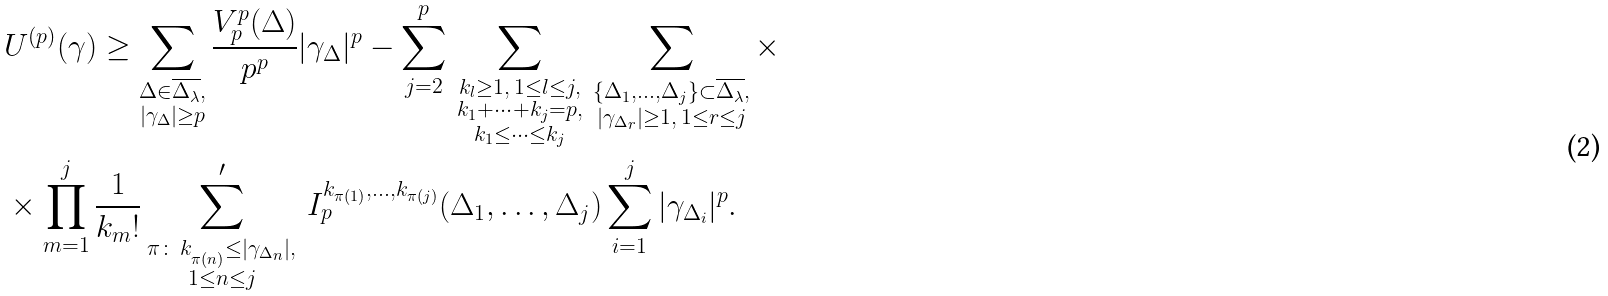<formula> <loc_0><loc_0><loc_500><loc_500>& U ^ { ( p ) } ( \gamma ) \geq \sum _ { \substack { \Delta \in \overline { \Delta _ { \lambda } } , \\ | \gamma _ { \Delta } | \geq p } } \frac { V _ { p } ^ { p } ( \Delta ) } { p ^ { p } } | \gamma _ { \Delta } | ^ { p } - \sum _ { j = 2 } ^ { p } \, \sum _ { \substack { k _ { l } \geq 1 , \, 1 \leq l \leq j , \\ k _ { 1 } + \cdots + k _ { j } = p , \\ k _ { 1 } \leq \dots \leq k _ { j } } } \, \sum _ { \substack { \{ \Delta _ { 1 } , \dots , \Delta _ { j } \} \subset \overline { \Delta _ { \lambda } } , \\ | \gamma _ { \Delta _ { r } } | \geq 1 , \, 1 \leq r \leq j } } \times \\ & \times \prod _ { m = 1 } ^ { j } \frac { 1 } { k _ { m } ! } \sum ^ { \prime } _ { \substack { \pi \colon \, k _ { _ { \pi ( n ) } } \leq | \gamma _ { \Delta _ { n } } | , \\ 1 \leq n \leq j } } \, I _ { p } ^ { k _ { \pi ( 1 ) } , \dots , k _ { \pi ( j ) } } ( \Delta _ { 1 } , \dots , \Delta _ { j } ) \sum _ { i = 1 } ^ { j } | \gamma _ { \Delta _ { i } } | ^ { p } .</formula> 